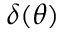<formula> <loc_0><loc_0><loc_500><loc_500>\delta ( \theta )</formula> 